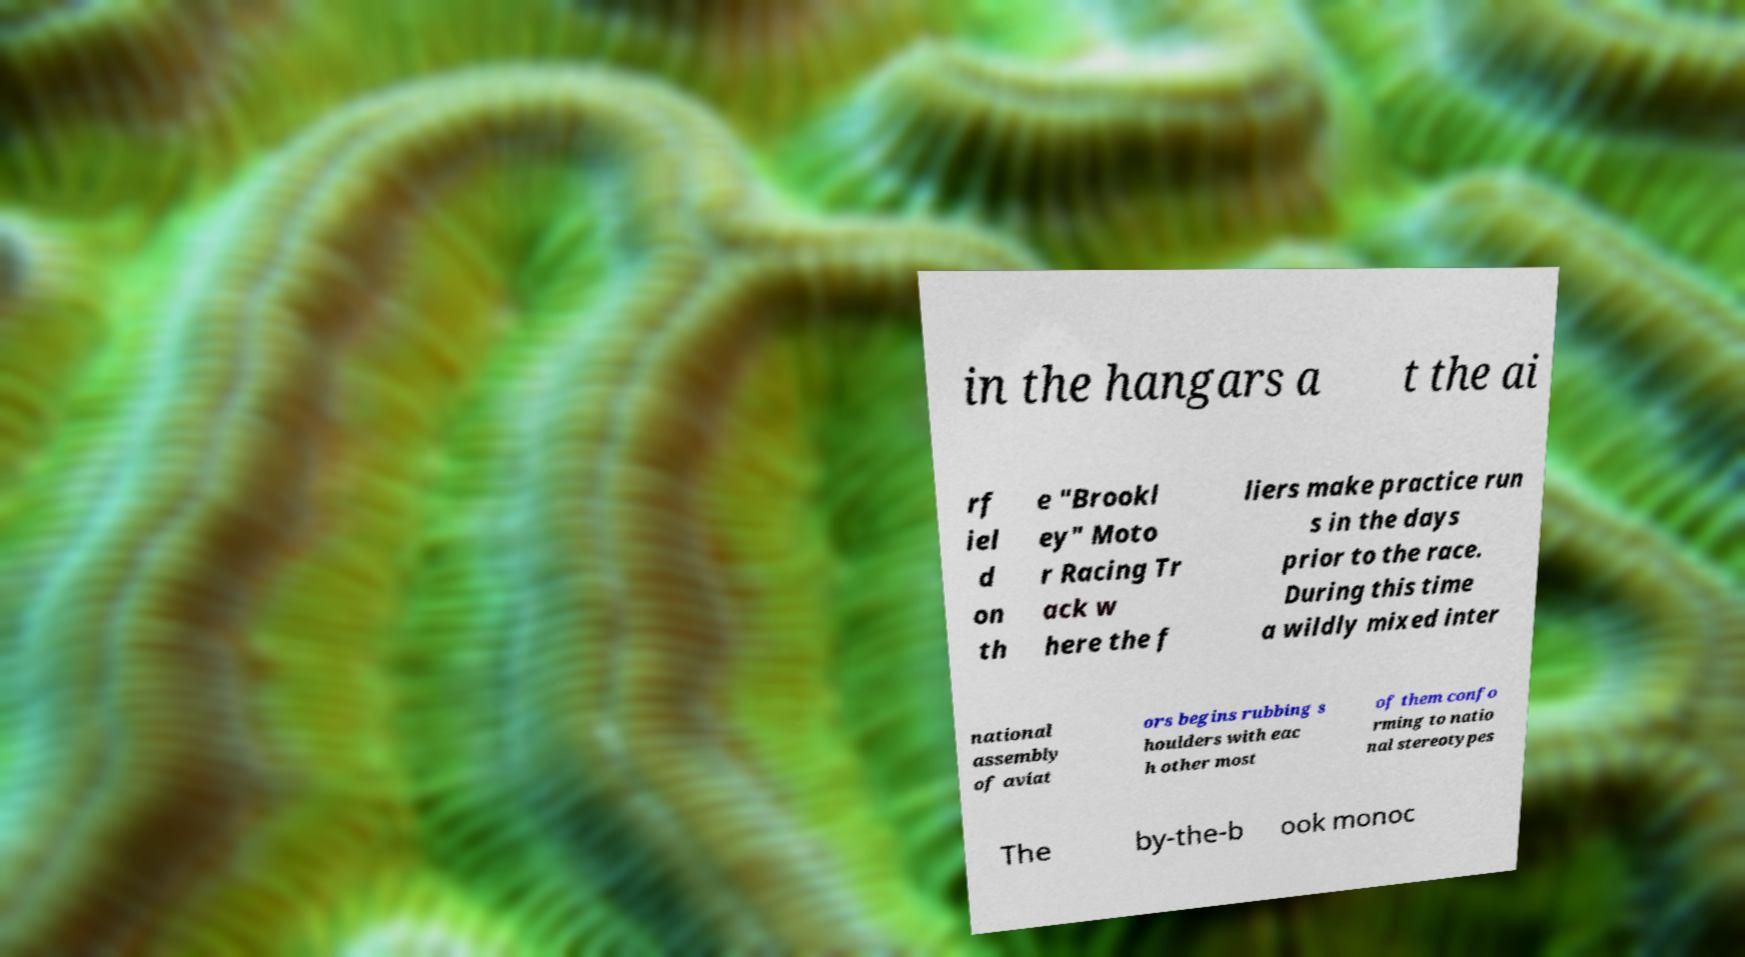For documentation purposes, I need the text within this image transcribed. Could you provide that? in the hangars a t the ai rf iel d on th e "Brookl ey" Moto r Racing Tr ack w here the f liers make practice run s in the days prior to the race. During this time a wildly mixed inter national assembly of aviat ors begins rubbing s houlders with eac h other most of them confo rming to natio nal stereotypes The by-the-b ook monoc 